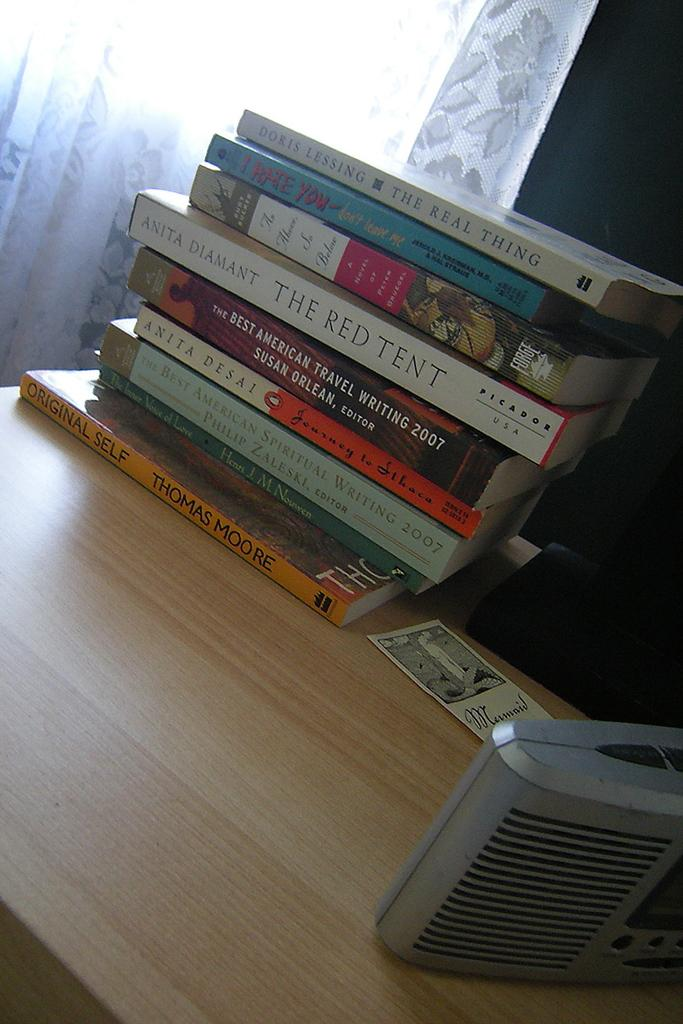<image>
Give a short and clear explanation of the subsequent image. A small stack of books is topped by one titled The Real Thing. 